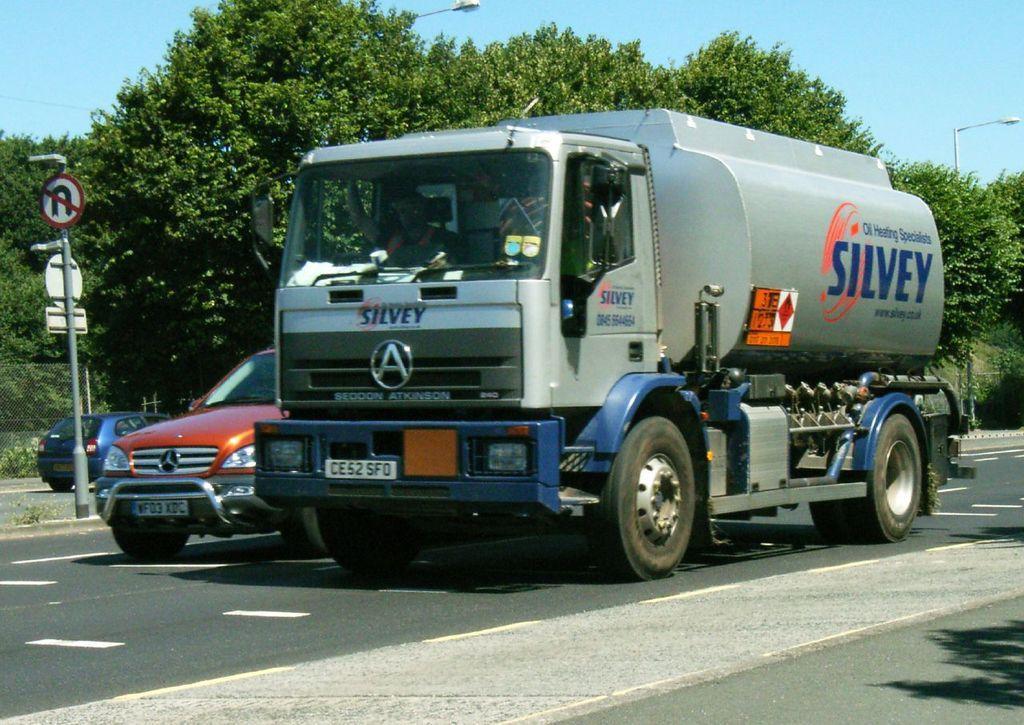Please provide a concise description of this image. In this picture we can see two truck and a car on a road and aside to this road we have sign board,pole, trees and in the background we can see sky, lights. 